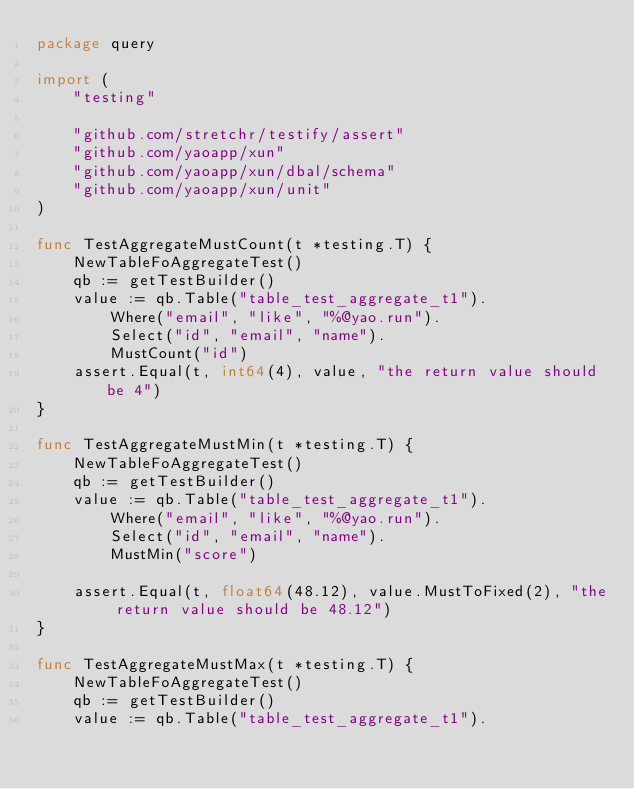Convert code to text. <code><loc_0><loc_0><loc_500><loc_500><_Go_>package query

import (
	"testing"

	"github.com/stretchr/testify/assert"
	"github.com/yaoapp/xun"
	"github.com/yaoapp/xun/dbal/schema"
	"github.com/yaoapp/xun/unit"
)

func TestAggregateMustCount(t *testing.T) {
	NewTableFoAggregateTest()
	qb := getTestBuilder()
	value := qb.Table("table_test_aggregate_t1").
		Where("email", "like", "%@yao.run").
		Select("id", "email", "name").
		MustCount("id")
	assert.Equal(t, int64(4), value, "the return value should be 4")
}

func TestAggregateMustMin(t *testing.T) {
	NewTableFoAggregateTest()
	qb := getTestBuilder()
	value := qb.Table("table_test_aggregate_t1").
		Where("email", "like", "%@yao.run").
		Select("id", "email", "name").
		MustMin("score")

	assert.Equal(t, float64(48.12), value.MustToFixed(2), "the return value should be 48.12")
}

func TestAggregateMustMax(t *testing.T) {
	NewTableFoAggregateTest()
	qb := getTestBuilder()
	value := qb.Table("table_test_aggregate_t1").</code> 